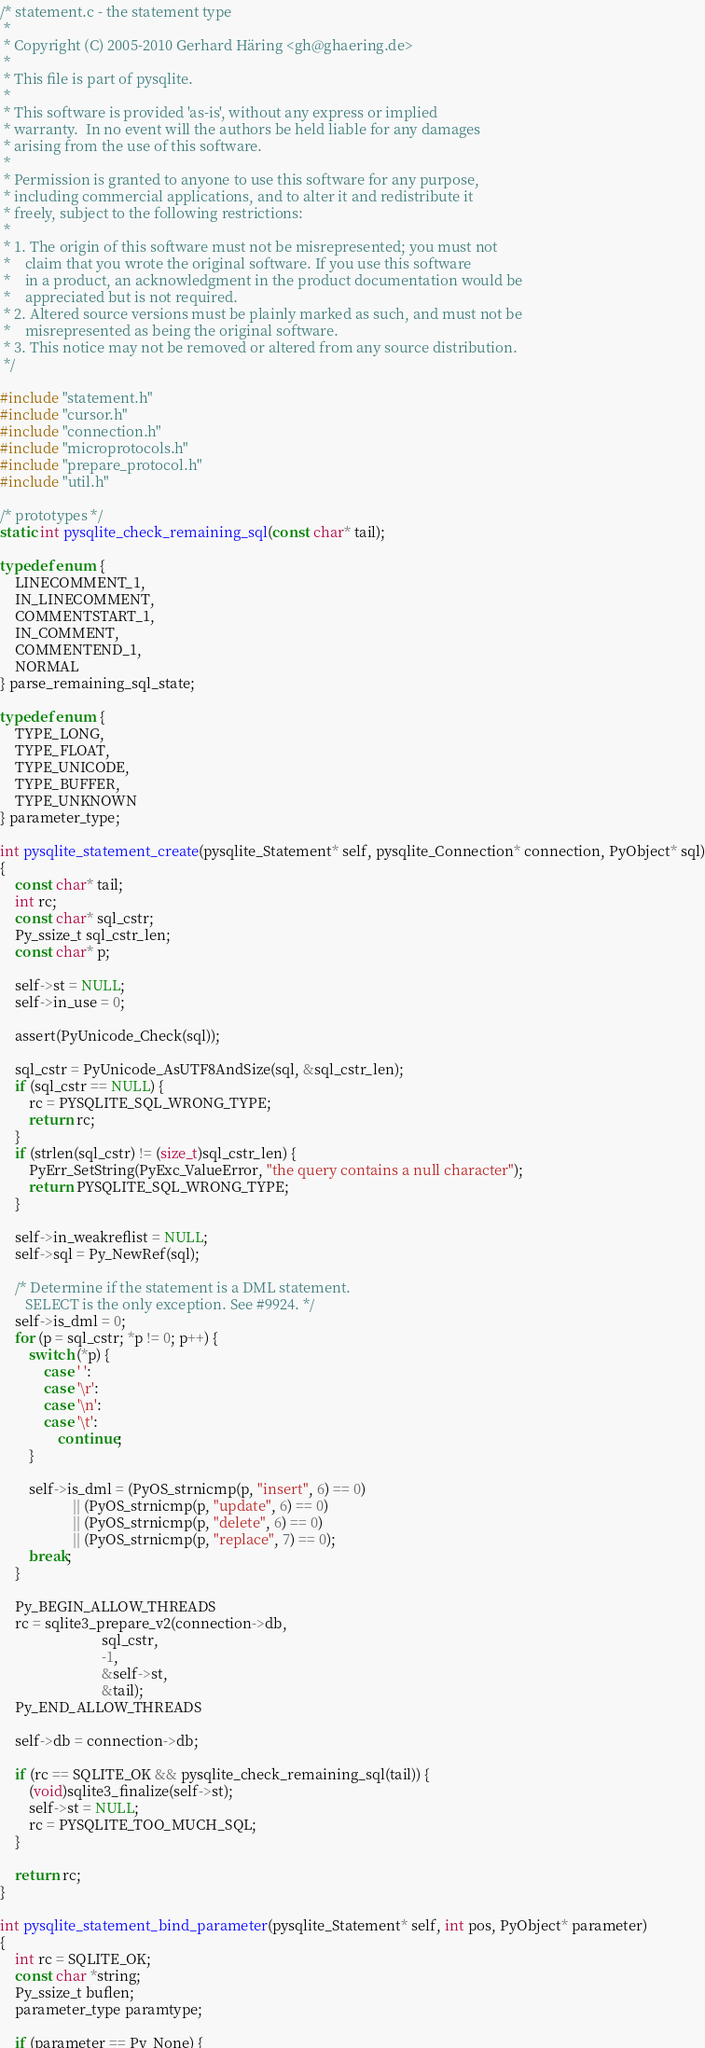<code> <loc_0><loc_0><loc_500><loc_500><_C_>/* statement.c - the statement type
 *
 * Copyright (C) 2005-2010 Gerhard Häring <gh@ghaering.de>
 *
 * This file is part of pysqlite.
 *
 * This software is provided 'as-is', without any express or implied
 * warranty.  In no event will the authors be held liable for any damages
 * arising from the use of this software.
 *
 * Permission is granted to anyone to use this software for any purpose,
 * including commercial applications, and to alter it and redistribute it
 * freely, subject to the following restrictions:
 *
 * 1. The origin of this software must not be misrepresented; you must not
 *    claim that you wrote the original software. If you use this software
 *    in a product, an acknowledgment in the product documentation would be
 *    appreciated but is not required.
 * 2. Altered source versions must be plainly marked as such, and must not be
 *    misrepresented as being the original software.
 * 3. This notice may not be removed or altered from any source distribution.
 */

#include "statement.h"
#include "cursor.h"
#include "connection.h"
#include "microprotocols.h"
#include "prepare_protocol.h"
#include "util.h"

/* prototypes */
static int pysqlite_check_remaining_sql(const char* tail);

typedef enum {
    LINECOMMENT_1,
    IN_LINECOMMENT,
    COMMENTSTART_1,
    IN_COMMENT,
    COMMENTEND_1,
    NORMAL
} parse_remaining_sql_state;

typedef enum {
    TYPE_LONG,
    TYPE_FLOAT,
    TYPE_UNICODE,
    TYPE_BUFFER,
    TYPE_UNKNOWN
} parameter_type;

int pysqlite_statement_create(pysqlite_Statement* self, pysqlite_Connection* connection, PyObject* sql)
{
    const char* tail;
    int rc;
    const char* sql_cstr;
    Py_ssize_t sql_cstr_len;
    const char* p;

    self->st = NULL;
    self->in_use = 0;

    assert(PyUnicode_Check(sql));

    sql_cstr = PyUnicode_AsUTF8AndSize(sql, &sql_cstr_len);
    if (sql_cstr == NULL) {
        rc = PYSQLITE_SQL_WRONG_TYPE;
        return rc;
    }
    if (strlen(sql_cstr) != (size_t)sql_cstr_len) {
        PyErr_SetString(PyExc_ValueError, "the query contains a null character");
        return PYSQLITE_SQL_WRONG_TYPE;
    }

    self->in_weakreflist = NULL;
    self->sql = Py_NewRef(sql);

    /* Determine if the statement is a DML statement.
       SELECT is the only exception. See #9924. */
    self->is_dml = 0;
    for (p = sql_cstr; *p != 0; p++) {
        switch (*p) {
            case ' ':
            case '\r':
            case '\n':
            case '\t':
                continue;
        }

        self->is_dml = (PyOS_strnicmp(p, "insert", 6) == 0)
                    || (PyOS_strnicmp(p, "update", 6) == 0)
                    || (PyOS_strnicmp(p, "delete", 6) == 0)
                    || (PyOS_strnicmp(p, "replace", 7) == 0);
        break;
    }

    Py_BEGIN_ALLOW_THREADS
    rc = sqlite3_prepare_v2(connection->db,
                            sql_cstr,
                            -1,
                            &self->st,
                            &tail);
    Py_END_ALLOW_THREADS

    self->db = connection->db;

    if (rc == SQLITE_OK && pysqlite_check_remaining_sql(tail)) {
        (void)sqlite3_finalize(self->st);
        self->st = NULL;
        rc = PYSQLITE_TOO_MUCH_SQL;
    }

    return rc;
}

int pysqlite_statement_bind_parameter(pysqlite_Statement* self, int pos, PyObject* parameter)
{
    int rc = SQLITE_OK;
    const char *string;
    Py_ssize_t buflen;
    parameter_type paramtype;

    if (parameter == Py_None) {</code> 